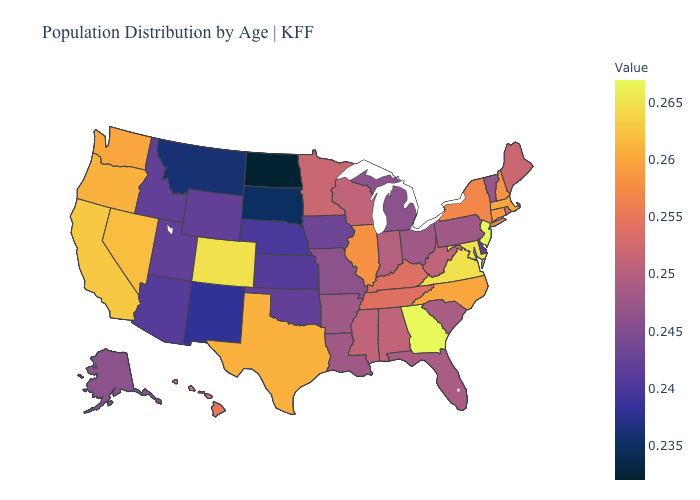Does Minnesota have a higher value than Pennsylvania?
Be succinct. Yes. Does New Mexico have a higher value than North Dakota?
Keep it brief. Yes. Is the legend a continuous bar?
Give a very brief answer. Yes. Which states have the highest value in the USA?
Write a very short answer. Georgia, New Jersey. Which states have the lowest value in the South?
Give a very brief answer. Delaware, Oklahoma. 